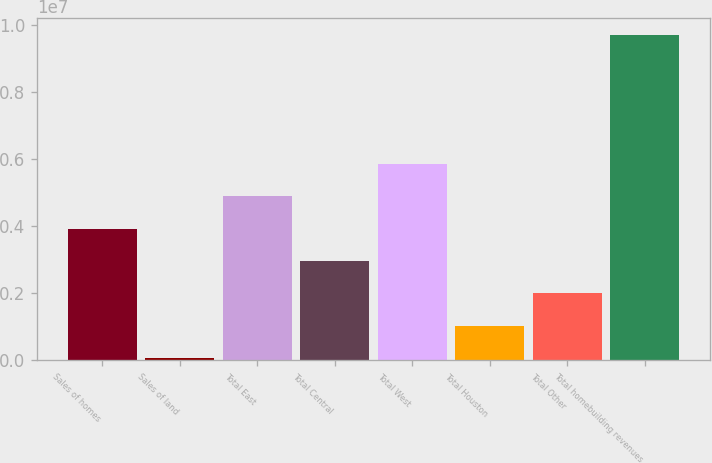Convert chart to OTSL. <chart><loc_0><loc_0><loc_500><loc_500><bar_chart><fcel>Sales of homes<fcel>Sales of land<fcel>Total East<fcel>Total Central<fcel>Total West<fcel>Total Houston<fcel>Total Other<fcel>Total homebuilding revenues<nl><fcel>3.93017e+06<fcel>63452<fcel>4.89685e+06<fcel>2.96349e+06<fcel>5.86353e+06<fcel>1.03013e+06<fcel>1.99681e+06<fcel>9.73025e+06<nl></chart> 